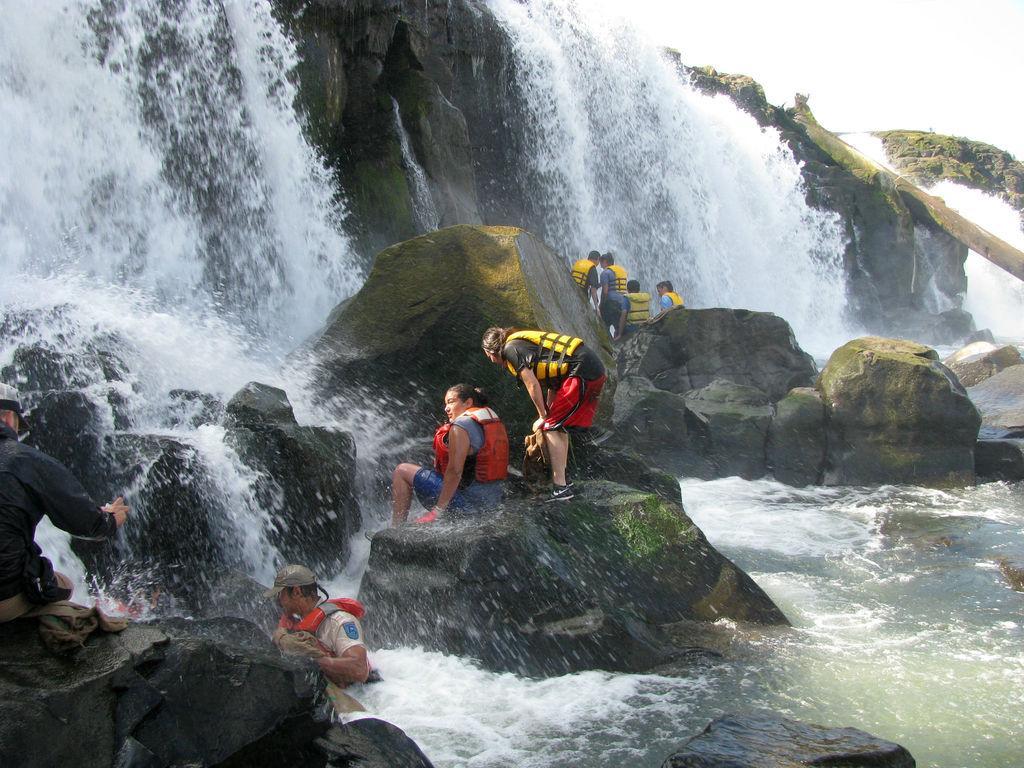Please provide a concise description of this image. This is the waterfalls with the water flowing. These are the rocks. I can see few people standing and few people siting. Here is another person standing in the water. 